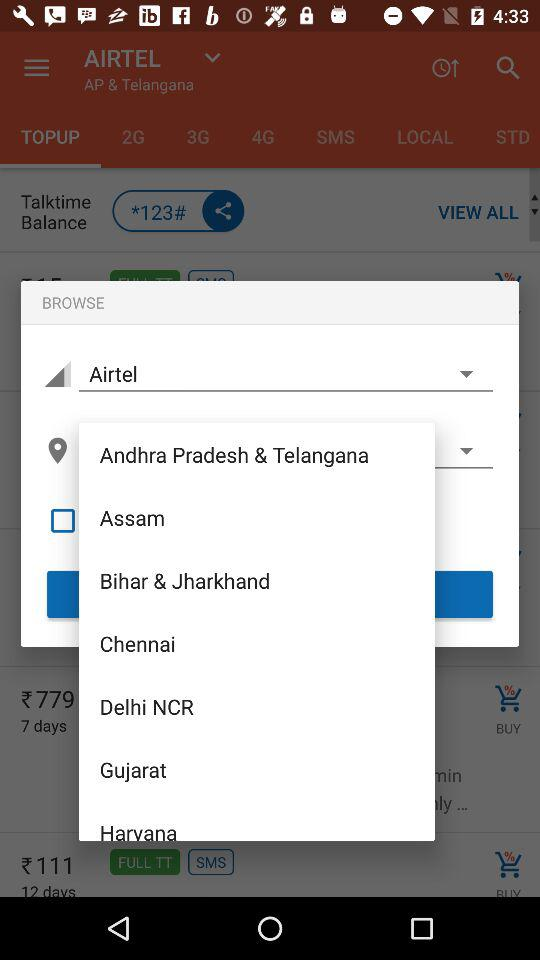What is the number to check the talktime balance? The number to check the talktime balance is *123#. 